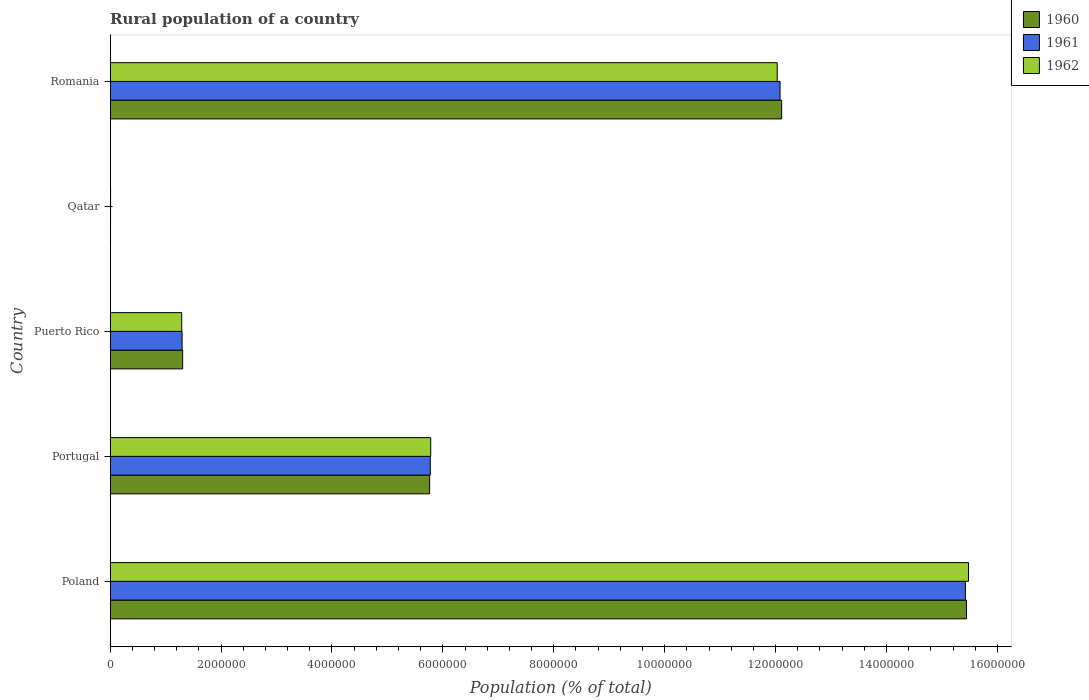Are the number of bars on each tick of the Y-axis equal?
Your answer should be compact. Yes. How many bars are there on the 1st tick from the bottom?
Make the answer very short. 3. What is the label of the 2nd group of bars from the top?
Give a very brief answer. Qatar. In how many cases, is the number of bars for a given country not equal to the number of legend labels?
Your response must be concise. 0. What is the rural population in 1962 in Romania?
Provide a short and direct response. 1.20e+07. Across all countries, what is the maximum rural population in 1961?
Your response must be concise. 1.54e+07. Across all countries, what is the minimum rural population in 1962?
Provide a short and direct response. 7809. In which country was the rural population in 1961 maximum?
Your answer should be very brief. Poland. In which country was the rural population in 1960 minimum?
Your answer should be compact. Qatar. What is the total rural population in 1962 in the graph?
Ensure brevity in your answer.  3.46e+07. What is the difference between the rural population in 1960 in Poland and that in Romania?
Provide a succinct answer. 3.33e+06. What is the difference between the rural population in 1962 in Poland and the rural population in 1960 in Portugal?
Keep it short and to the point. 9.72e+06. What is the average rural population in 1961 per country?
Your response must be concise. 6.92e+06. What is the difference between the rural population in 1961 and rural population in 1962 in Puerto Rico?
Offer a very short reply. 6800. In how many countries, is the rural population in 1961 greater than 4800000 %?
Offer a terse response. 3. What is the ratio of the rural population in 1960 in Qatar to that in Romania?
Offer a terse response. 0. Is the rural population in 1960 in Poland less than that in Puerto Rico?
Give a very brief answer. No. What is the difference between the highest and the second highest rural population in 1961?
Give a very brief answer. 3.34e+06. What is the difference between the highest and the lowest rural population in 1961?
Your answer should be very brief. 1.54e+07. Is it the case that in every country, the sum of the rural population in 1962 and rural population in 1961 is greater than the rural population in 1960?
Offer a terse response. Yes. How many bars are there?
Ensure brevity in your answer.  15. Are all the bars in the graph horizontal?
Keep it short and to the point. Yes. What is the difference between two consecutive major ticks on the X-axis?
Your answer should be compact. 2.00e+06. Are the values on the major ticks of X-axis written in scientific E-notation?
Provide a short and direct response. No. Where does the legend appear in the graph?
Your response must be concise. Top right. What is the title of the graph?
Ensure brevity in your answer.  Rural population of a country. Does "1999" appear as one of the legend labels in the graph?
Keep it short and to the point. No. What is the label or title of the X-axis?
Ensure brevity in your answer.  Population (% of total). What is the label or title of the Y-axis?
Provide a succinct answer. Country. What is the Population (% of total) in 1960 in Poland?
Your response must be concise. 1.54e+07. What is the Population (% of total) in 1961 in Poland?
Give a very brief answer. 1.54e+07. What is the Population (% of total) of 1962 in Poland?
Make the answer very short. 1.55e+07. What is the Population (% of total) in 1960 in Portugal?
Keep it short and to the point. 5.76e+06. What is the Population (% of total) in 1961 in Portugal?
Ensure brevity in your answer.  5.77e+06. What is the Population (% of total) of 1962 in Portugal?
Keep it short and to the point. 5.78e+06. What is the Population (% of total) of 1960 in Puerto Rico?
Provide a succinct answer. 1.31e+06. What is the Population (% of total) of 1961 in Puerto Rico?
Your answer should be compact. 1.30e+06. What is the Population (% of total) of 1962 in Puerto Rico?
Keep it short and to the point. 1.29e+06. What is the Population (% of total) in 1960 in Qatar?
Make the answer very short. 6966. What is the Population (% of total) of 1961 in Qatar?
Give a very brief answer. 7347. What is the Population (% of total) of 1962 in Qatar?
Provide a short and direct response. 7809. What is the Population (% of total) in 1960 in Romania?
Give a very brief answer. 1.21e+07. What is the Population (% of total) of 1961 in Romania?
Offer a terse response. 1.21e+07. What is the Population (% of total) of 1962 in Romania?
Your answer should be very brief. 1.20e+07. Across all countries, what is the maximum Population (% of total) in 1960?
Your answer should be very brief. 1.54e+07. Across all countries, what is the maximum Population (% of total) in 1961?
Offer a terse response. 1.54e+07. Across all countries, what is the maximum Population (% of total) in 1962?
Provide a short and direct response. 1.55e+07. Across all countries, what is the minimum Population (% of total) of 1960?
Give a very brief answer. 6966. Across all countries, what is the minimum Population (% of total) in 1961?
Give a very brief answer. 7347. Across all countries, what is the minimum Population (% of total) in 1962?
Your answer should be very brief. 7809. What is the total Population (% of total) in 1960 in the graph?
Ensure brevity in your answer.  3.46e+07. What is the total Population (% of total) of 1961 in the graph?
Your response must be concise. 3.46e+07. What is the total Population (% of total) in 1962 in the graph?
Offer a very short reply. 3.46e+07. What is the difference between the Population (% of total) in 1960 in Poland and that in Portugal?
Make the answer very short. 9.68e+06. What is the difference between the Population (% of total) in 1961 in Poland and that in Portugal?
Provide a succinct answer. 9.65e+06. What is the difference between the Population (% of total) of 1962 in Poland and that in Portugal?
Offer a terse response. 9.70e+06. What is the difference between the Population (% of total) of 1960 in Poland and that in Puerto Rico?
Provide a short and direct response. 1.41e+07. What is the difference between the Population (% of total) of 1961 in Poland and that in Puerto Rico?
Your answer should be compact. 1.41e+07. What is the difference between the Population (% of total) in 1962 in Poland and that in Puerto Rico?
Your answer should be compact. 1.42e+07. What is the difference between the Population (% of total) in 1960 in Poland and that in Qatar?
Provide a succinct answer. 1.54e+07. What is the difference between the Population (% of total) in 1961 in Poland and that in Qatar?
Make the answer very short. 1.54e+07. What is the difference between the Population (% of total) of 1962 in Poland and that in Qatar?
Make the answer very short. 1.55e+07. What is the difference between the Population (% of total) in 1960 in Poland and that in Romania?
Your answer should be very brief. 3.33e+06. What is the difference between the Population (% of total) of 1961 in Poland and that in Romania?
Provide a succinct answer. 3.34e+06. What is the difference between the Population (% of total) of 1962 in Poland and that in Romania?
Offer a very short reply. 3.45e+06. What is the difference between the Population (% of total) in 1960 in Portugal and that in Puerto Rico?
Keep it short and to the point. 4.45e+06. What is the difference between the Population (% of total) in 1961 in Portugal and that in Puerto Rico?
Your response must be concise. 4.48e+06. What is the difference between the Population (% of total) in 1962 in Portugal and that in Puerto Rico?
Your answer should be very brief. 4.49e+06. What is the difference between the Population (% of total) in 1960 in Portugal and that in Qatar?
Give a very brief answer. 5.75e+06. What is the difference between the Population (% of total) in 1961 in Portugal and that in Qatar?
Give a very brief answer. 5.77e+06. What is the difference between the Population (% of total) in 1962 in Portugal and that in Qatar?
Provide a succinct answer. 5.77e+06. What is the difference between the Population (% of total) in 1960 in Portugal and that in Romania?
Make the answer very short. -6.35e+06. What is the difference between the Population (% of total) of 1961 in Portugal and that in Romania?
Keep it short and to the point. -6.31e+06. What is the difference between the Population (% of total) of 1962 in Portugal and that in Romania?
Ensure brevity in your answer.  -6.25e+06. What is the difference between the Population (% of total) of 1960 in Puerto Rico and that in Qatar?
Offer a terse response. 1.30e+06. What is the difference between the Population (% of total) in 1961 in Puerto Rico and that in Qatar?
Provide a succinct answer. 1.29e+06. What is the difference between the Population (% of total) in 1962 in Puerto Rico and that in Qatar?
Provide a short and direct response. 1.28e+06. What is the difference between the Population (% of total) of 1960 in Puerto Rico and that in Romania?
Your answer should be very brief. -1.08e+07. What is the difference between the Population (% of total) of 1961 in Puerto Rico and that in Romania?
Your answer should be compact. -1.08e+07. What is the difference between the Population (% of total) of 1962 in Puerto Rico and that in Romania?
Make the answer very short. -1.07e+07. What is the difference between the Population (% of total) of 1960 in Qatar and that in Romania?
Offer a terse response. -1.21e+07. What is the difference between the Population (% of total) of 1961 in Qatar and that in Romania?
Provide a short and direct response. -1.21e+07. What is the difference between the Population (% of total) in 1962 in Qatar and that in Romania?
Provide a short and direct response. -1.20e+07. What is the difference between the Population (% of total) in 1960 in Poland and the Population (% of total) in 1961 in Portugal?
Your response must be concise. 9.67e+06. What is the difference between the Population (% of total) in 1960 in Poland and the Population (% of total) in 1962 in Portugal?
Provide a short and direct response. 9.66e+06. What is the difference between the Population (% of total) of 1961 in Poland and the Population (% of total) of 1962 in Portugal?
Provide a short and direct response. 9.64e+06. What is the difference between the Population (% of total) of 1960 in Poland and the Population (% of total) of 1961 in Puerto Rico?
Give a very brief answer. 1.41e+07. What is the difference between the Population (% of total) of 1960 in Poland and the Population (% of total) of 1962 in Puerto Rico?
Offer a terse response. 1.42e+07. What is the difference between the Population (% of total) in 1961 in Poland and the Population (% of total) in 1962 in Puerto Rico?
Your response must be concise. 1.41e+07. What is the difference between the Population (% of total) in 1960 in Poland and the Population (% of total) in 1961 in Qatar?
Give a very brief answer. 1.54e+07. What is the difference between the Population (% of total) in 1960 in Poland and the Population (% of total) in 1962 in Qatar?
Provide a succinct answer. 1.54e+07. What is the difference between the Population (% of total) in 1961 in Poland and the Population (% of total) in 1962 in Qatar?
Keep it short and to the point. 1.54e+07. What is the difference between the Population (% of total) of 1960 in Poland and the Population (% of total) of 1961 in Romania?
Your response must be concise. 3.36e+06. What is the difference between the Population (% of total) of 1960 in Poland and the Population (% of total) of 1962 in Romania?
Provide a short and direct response. 3.41e+06. What is the difference between the Population (% of total) of 1961 in Poland and the Population (% of total) of 1962 in Romania?
Offer a very short reply. 3.39e+06. What is the difference between the Population (% of total) in 1960 in Portugal and the Population (% of total) in 1961 in Puerto Rico?
Provide a short and direct response. 4.46e+06. What is the difference between the Population (% of total) of 1960 in Portugal and the Population (% of total) of 1962 in Puerto Rico?
Your answer should be compact. 4.47e+06. What is the difference between the Population (% of total) in 1961 in Portugal and the Population (% of total) in 1962 in Puerto Rico?
Offer a very short reply. 4.48e+06. What is the difference between the Population (% of total) in 1960 in Portugal and the Population (% of total) in 1961 in Qatar?
Give a very brief answer. 5.75e+06. What is the difference between the Population (% of total) of 1960 in Portugal and the Population (% of total) of 1962 in Qatar?
Ensure brevity in your answer.  5.75e+06. What is the difference between the Population (% of total) in 1961 in Portugal and the Population (% of total) in 1962 in Qatar?
Your answer should be very brief. 5.77e+06. What is the difference between the Population (% of total) in 1960 in Portugal and the Population (% of total) in 1961 in Romania?
Provide a succinct answer. -6.32e+06. What is the difference between the Population (% of total) of 1960 in Portugal and the Population (% of total) of 1962 in Romania?
Offer a terse response. -6.27e+06. What is the difference between the Population (% of total) in 1961 in Portugal and the Population (% of total) in 1962 in Romania?
Your answer should be compact. -6.26e+06. What is the difference between the Population (% of total) of 1960 in Puerto Rico and the Population (% of total) of 1961 in Qatar?
Give a very brief answer. 1.30e+06. What is the difference between the Population (% of total) in 1960 in Puerto Rico and the Population (% of total) in 1962 in Qatar?
Give a very brief answer. 1.30e+06. What is the difference between the Population (% of total) of 1961 in Puerto Rico and the Population (% of total) of 1962 in Qatar?
Provide a succinct answer. 1.29e+06. What is the difference between the Population (% of total) of 1960 in Puerto Rico and the Population (% of total) of 1961 in Romania?
Give a very brief answer. -1.08e+07. What is the difference between the Population (% of total) in 1960 in Puerto Rico and the Population (% of total) in 1962 in Romania?
Your response must be concise. -1.07e+07. What is the difference between the Population (% of total) of 1961 in Puerto Rico and the Population (% of total) of 1962 in Romania?
Offer a terse response. -1.07e+07. What is the difference between the Population (% of total) of 1960 in Qatar and the Population (% of total) of 1961 in Romania?
Keep it short and to the point. -1.21e+07. What is the difference between the Population (% of total) in 1960 in Qatar and the Population (% of total) in 1962 in Romania?
Give a very brief answer. -1.20e+07. What is the difference between the Population (% of total) in 1961 in Qatar and the Population (% of total) in 1962 in Romania?
Keep it short and to the point. -1.20e+07. What is the average Population (% of total) in 1960 per country?
Your answer should be very brief. 6.93e+06. What is the average Population (% of total) of 1961 per country?
Your response must be concise. 6.92e+06. What is the average Population (% of total) of 1962 per country?
Your answer should be very brief. 6.92e+06. What is the difference between the Population (% of total) of 1960 and Population (% of total) of 1961 in Poland?
Make the answer very short. 2.01e+04. What is the difference between the Population (% of total) in 1960 and Population (% of total) in 1962 in Poland?
Make the answer very short. -3.63e+04. What is the difference between the Population (% of total) in 1961 and Population (% of total) in 1962 in Poland?
Your answer should be very brief. -5.64e+04. What is the difference between the Population (% of total) of 1960 and Population (% of total) of 1961 in Portugal?
Offer a terse response. -1.18e+04. What is the difference between the Population (% of total) in 1960 and Population (% of total) in 1962 in Portugal?
Provide a short and direct response. -1.97e+04. What is the difference between the Population (% of total) of 1961 and Population (% of total) of 1962 in Portugal?
Provide a short and direct response. -7815. What is the difference between the Population (% of total) of 1960 and Population (% of total) of 1961 in Puerto Rico?
Make the answer very short. 1.01e+04. What is the difference between the Population (% of total) of 1960 and Population (% of total) of 1962 in Puerto Rico?
Ensure brevity in your answer.  1.69e+04. What is the difference between the Population (% of total) of 1961 and Population (% of total) of 1962 in Puerto Rico?
Keep it short and to the point. 6800. What is the difference between the Population (% of total) of 1960 and Population (% of total) of 1961 in Qatar?
Your answer should be very brief. -381. What is the difference between the Population (% of total) of 1960 and Population (% of total) of 1962 in Qatar?
Give a very brief answer. -843. What is the difference between the Population (% of total) of 1961 and Population (% of total) of 1962 in Qatar?
Your answer should be compact. -462. What is the difference between the Population (% of total) in 1960 and Population (% of total) in 1961 in Romania?
Offer a terse response. 2.95e+04. What is the difference between the Population (% of total) of 1960 and Population (% of total) of 1962 in Romania?
Make the answer very short. 7.98e+04. What is the difference between the Population (% of total) of 1961 and Population (% of total) of 1962 in Romania?
Ensure brevity in your answer.  5.03e+04. What is the ratio of the Population (% of total) in 1960 in Poland to that in Portugal?
Keep it short and to the point. 2.68. What is the ratio of the Population (% of total) of 1961 in Poland to that in Portugal?
Provide a short and direct response. 2.67. What is the ratio of the Population (% of total) in 1962 in Poland to that in Portugal?
Provide a succinct answer. 2.68. What is the ratio of the Population (% of total) of 1960 in Poland to that in Puerto Rico?
Your answer should be very brief. 11.81. What is the ratio of the Population (% of total) in 1961 in Poland to that in Puerto Rico?
Provide a succinct answer. 11.89. What is the ratio of the Population (% of total) in 1962 in Poland to that in Puerto Rico?
Make the answer very short. 11.99. What is the ratio of the Population (% of total) of 1960 in Poland to that in Qatar?
Make the answer very short. 2216.98. What is the ratio of the Population (% of total) of 1961 in Poland to that in Qatar?
Provide a short and direct response. 2099.27. What is the ratio of the Population (% of total) in 1962 in Poland to that in Qatar?
Ensure brevity in your answer.  1982.3. What is the ratio of the Population (% of total) in 1960 in Poland to that in Romania?
Provide a short and direct response. 1.28. What is the ratio of the Population (% of total) in 1961 in Poland to that in Romania?
Offer a terse response. 1.28. What is the ratio of the Population (% of total) of 1962 in Poland to that in Romania?
Your answer should be compact. 1.29. What is the ratio of the Population (% of total) of 1960 in Portugal to that in Puerto Rico?
Keep it short and to the point. 4.41. What is the ratio of the Population (% of total) of 1961 in Portugal to that in Puerto Rico?
Your answer should be compact. 4.45. What is the ratio of the Population (% of total) of 1962 in Portugal to that in Puerto Rico?
Make the answer very short. 4.48. What is the ratio of the Population (% of total) of 1960 in Portugal to that in Qatar?
Provide a succinct answer. 827.09. What is the ratio of the Population (% of total) in 1961 in Portugal to that in Qatar?
Your answer should be very brief. 785.81. What is the ratio of the Population (% of total) in 1962 in Portugal to that in Qatar?
Offer a terse response. 740.32. What is the ratio of the Population (% of total) of 1960 in Portugal to that in Romania?
Give a very brief answer. 0.48. What is the ratio of the Population (% of total) in 1961 in Portugal to that in Romania?
Offer a terse response. 0.48. What is the ratio of the Population (% of total) of 1962 in Portugal to that in Romania?
Offer a terse response. 0.48. What is the ratio of the Population (% of total) of 1960 in Puerto Rico to that in Qatar?
Offer a terse response. 187.71. What is the ratio of the Population (% of total) of 1961 in Puerto Rico to that in Qatar?
Your response must be concise. 176.6. What is the ratio of the Population (% of total) of 1962 in Puerto Rico to that in Qatar?
Make the answer very short. 165.28. What is the ratio of the Population (% of total) of 1960 in Puerto Rico to that in Romania?
Your answer should be very brief. 0.11. What is the ratio of the Population (% of total) of 1961 in Puerto Rico to that in Romania?
Give a very brief answer. 0.11. What is the ratio of the Population (% of total) in 1962 in Puerto Rico to that in Romania?
Your answer should be compact. 0.11. What is the ratio of the Population (% of total) in 1960 in Qatar to that in Romania?
Make the answer very short. 0. What is the ratio of the Population (% of total) of 1961 in Qatar to that in Romania?
Offer a terse response. 0. What is the ratio of the Population (% of total) in 1962 in Qatar to that in Romania?
Make the answer very short. 0. What is the difference between the highest and the second highest Population (% of total) in 1960?
Ensure brevity in your answer.  3.33e+06. What is the difference between the highest and the second highest Population (% of total) of 1961?
Your answer should be very brief. 3.34e+06. What is the difference between the highest and the second highest Population (% of total) in 1962?
Your answer should be compact. 3.45e+06. What is the difference between the highest and the lowest Population (% of total) in 1960?
Offer a terse response. 1.54e+07. What is the difference between the highest and the lowest Population (% of total) in 1961?
Your answer should be compact. 1.54e+07. What is the difference between the highest and the lowest Population (% of total) of 1962?
Keep it short and to the point. 1.55e+07. 